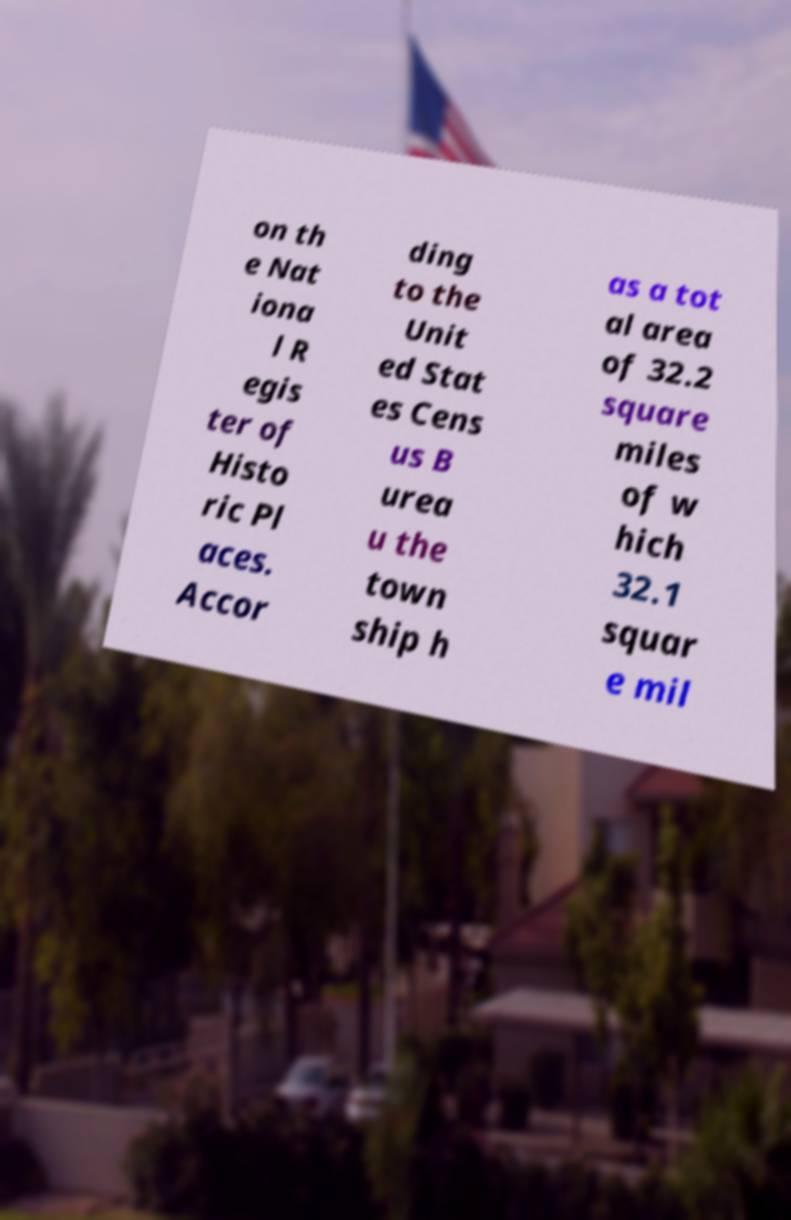There's text embedded in this image that I need extracted. Can you transcribe it verbatim? on th e Nat iona l R egis ter of Histo ric Pl aces. Accor ding to the Unit ed Stat es Cens us B urea u the town ship h as a tot al area of 32.2 square miles of w hich 32.1 squar e mil 